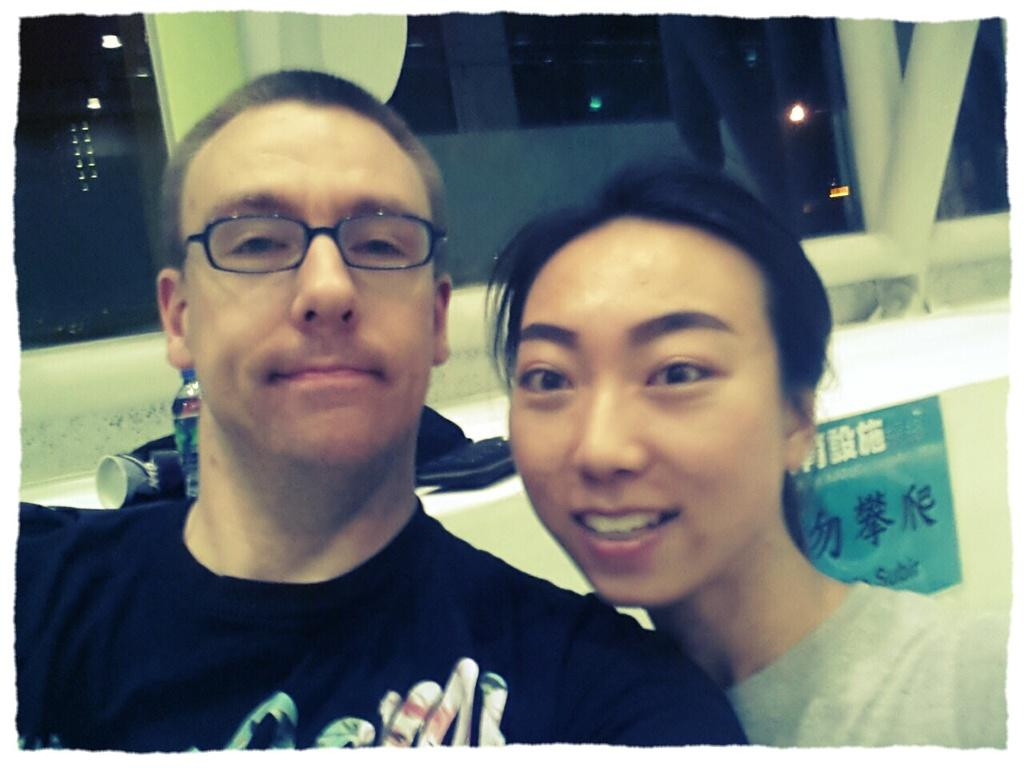How many people are in the image? There are two people in the image, a man and a woman. What are the man and woman doing in the image? The man and woman are looking at each other and smiling. Can you describe the man's appearance? The man is wearing glasses. What objects can be seen in the background of the image? There is a bottle, a poster, a glass, rods, and lights in the background of the image. How many babies are crawling on the floor in the image? There are no babies present in the image. What type of beetle can be seen on the poster in the background? There is no beetle present on the poster or in the image. 